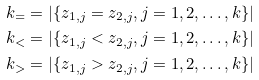Convert formula to latex. <formula><loc_0><loc_0><loc_500><loc_500>k _ { = } & = | \{ z _ { 1 , j } = z _ { 2 , j } , j = 1 , 2 , \dots , k \} | \\ k _ { < } & = | \{ z _ { 1 , j } < z _ { 2 , j } , j = 1 , 2 , \dots , k \} | \\ k _ { > } & = | \{ z _ { 1 , j } > z _ { 2 , j } , j = 1 , 2 , \dots , k \} |</formula> 